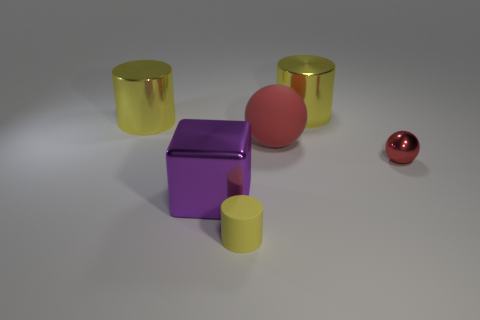What is the material of the small ball that is the same color as the big rubber ball?
Provide a short and direct response. Metal. What number of big objects are the same color as the matte cylinder?
Offer a very short reply. 2. There is a metal object that is the same color as the big sphere; what size is it?
Make the answer very short. Small. What is the size of the yellow metallic thing that is to the right of the cylinder in front of the big purple metallic thing?
Provide a succinct answer. Large. Do the purple shiny thing and the red metal thing have the same size?
Provide a succinct answer. No. There is a red metal sphere on the right side of the yellow metallic cylinder on the right side of the red rubber ball; is there a large ball that is in front of it?
Make the answer very short. No. What is the size of the purple thing?
Your response must be concise. Large. How many yellow metal things have the same size as the metallic sphere?
Make the answer very short. 0. What is the material of the other red thing that is the same shape as the small red metallic object?
Provide a short and direct response. Rubber. There is a big object that is both behind the large matte thing and on the right side of the large purple metal cube; what shape is it?
Provide a succinct answer. Cylinder. 